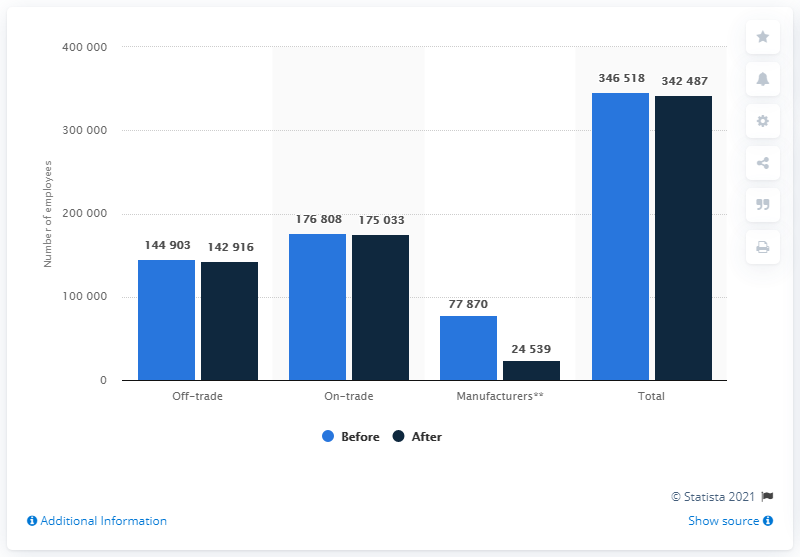Identify some key points in this picture. Off-trade beverage sales contribute approximately 144,903 jobs. It is estimated that the implementation of the sugar tax will result in the loss of approximately 144,903 jobs. 